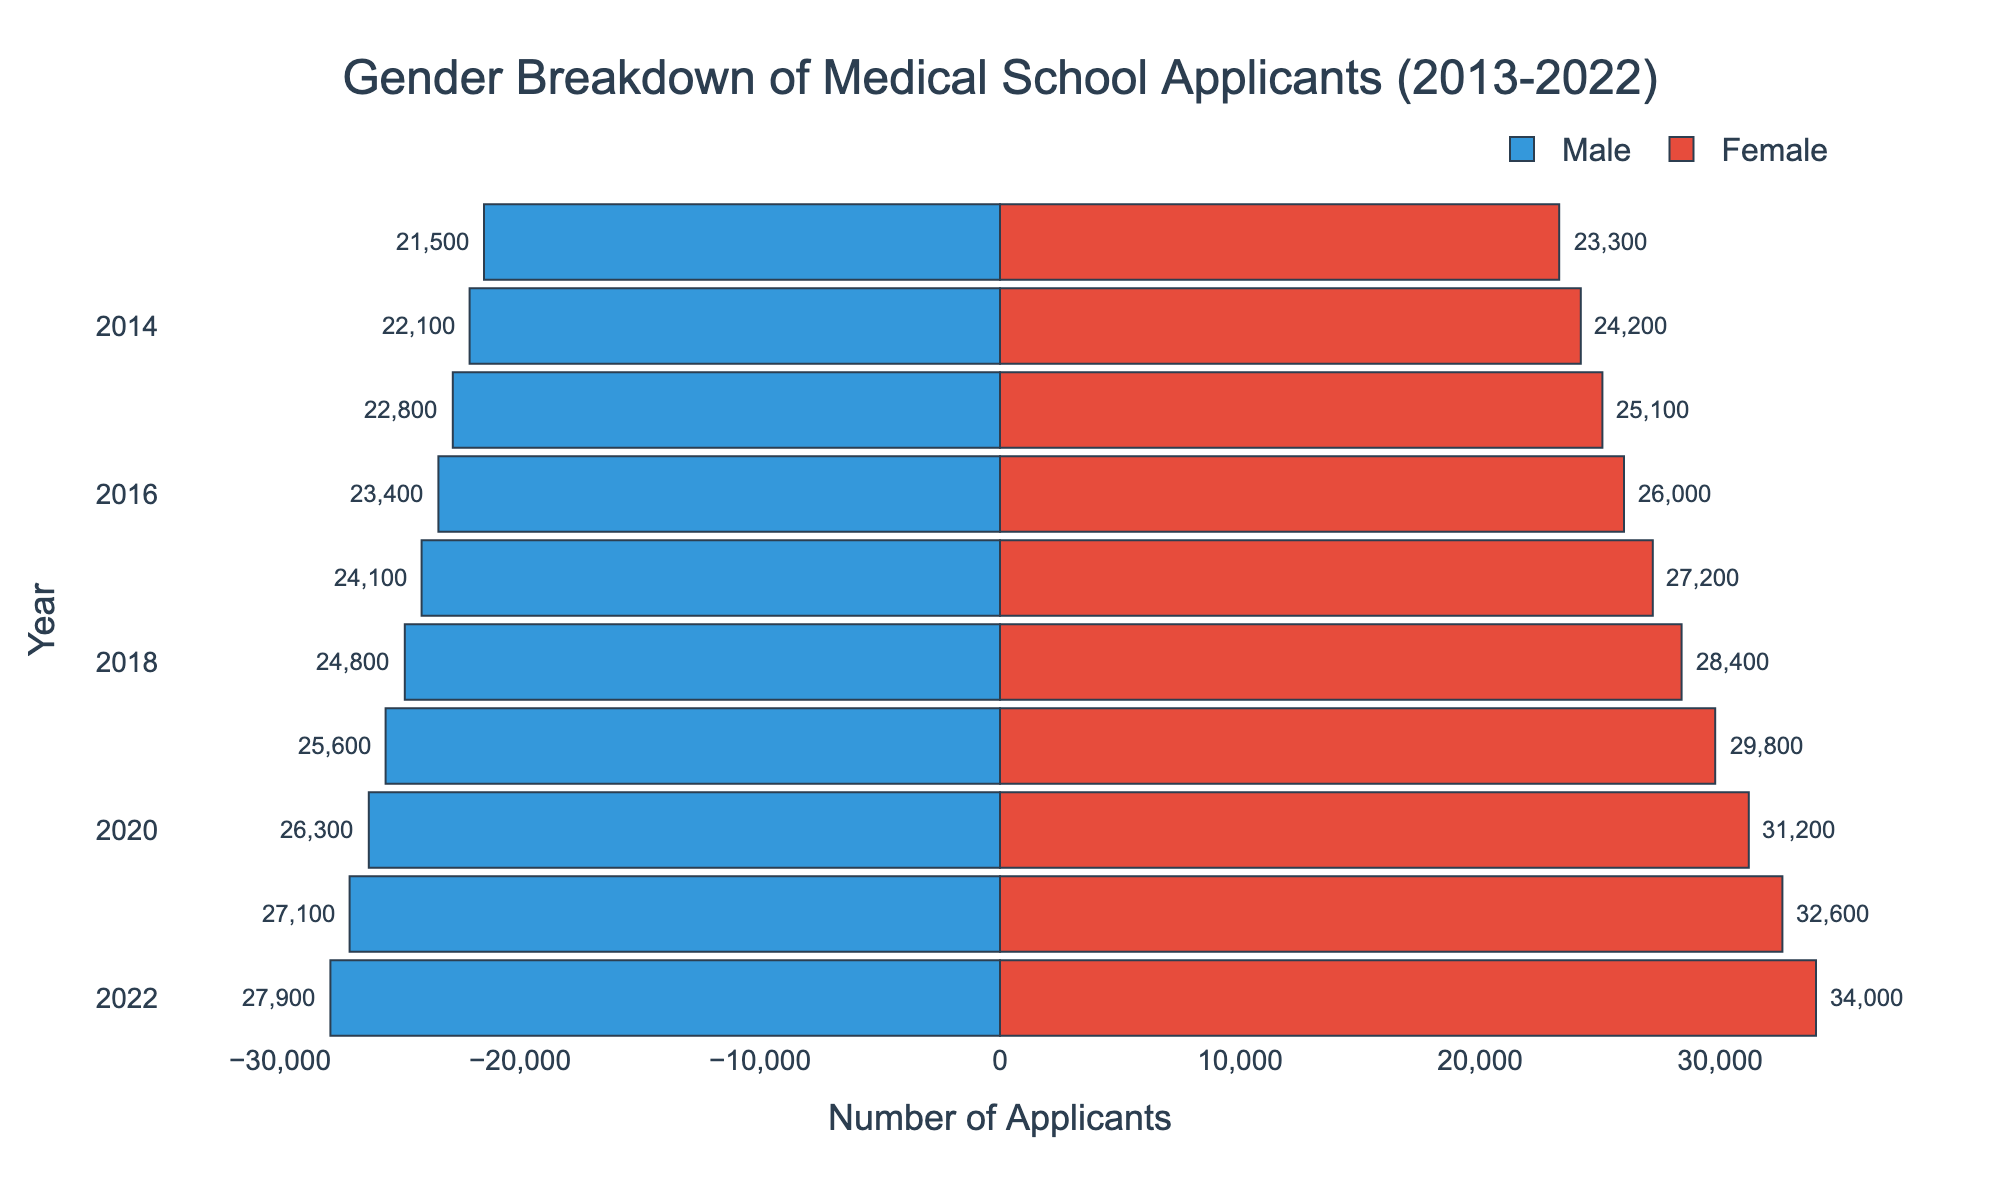What's the title of the figure? The title is usually placed at the top of the figure and it summarizes what the plot is about. In this case, you can see it centered above the bars.
Answer: Gender Breakdown of Medical School Applicants (2013-2022) How many applicants were there in total in 2022? To find the total number of applicants, you need to sum the applicants for both genders in the year 2022. The values are 27,900 for males and 34,000 for females. Therefore, the total is 27,900 + 34,000.
Answer: 61,900 In which year did the number of female applicants first exceed 30,000? You need to find the year where the female applicant bar first extends beyond the 30,000 mark. This bar can be identified by the year label on the y-axis and the value of the female bar.
Answer: 2019 What was the difference in the number of female and male applicants in 2021? Find the values for both male and female applicants in 2021 and then subtract the number of male applicants from the number of female applicants. The female applicants were 32,600 and the male applicants were 27,100. The difference is 32,600 - 27,100.
Answer: 5,500 Which year had the smallest gap between male and female applicants? You need to examine the length of the bars for each year and calculate the differences between male and female applicants for each year. The smallest difference can be observed by the smallest space between the ends of the male and female bars for those years.
Answer: 2013 What colors are used to represent male and female applicants? The bars for each gender are colored differently to distinguish them. You can determine this by looking at the color of the bars in the figure.
Answer: Blue for males and red for females How has the number of male applicants changed from 2013 to 2022? To observe the trend, you need to compare the length of the male bars from the first year to the last year in the dataset. Note the values: 21,500 in 2013 and 27,900 in 2022. Assess whether there has been an increase or decrease.
Answer: Increased Which year showed the highest number of female applicants? Find the year with the longest bar on the right side of the figure, representing the highest number of female applicants. The year corresponds to this bar.
Answer: 2022 What is the total increase in the number of applicants for both genders from 2013 to 2022? To find the total increase, calculate the sum of male and female applicants for both years separately, then subtract the 2013 totals from the 2022 totals. In 2013, the total was 21,500 (male) + 23,300 (female) = 44,800. In 2022, the total was 27,900 (male) + 34,000 (female) = 61,900. The increase is 61,900 - 44,800.
Answer: 17,100 